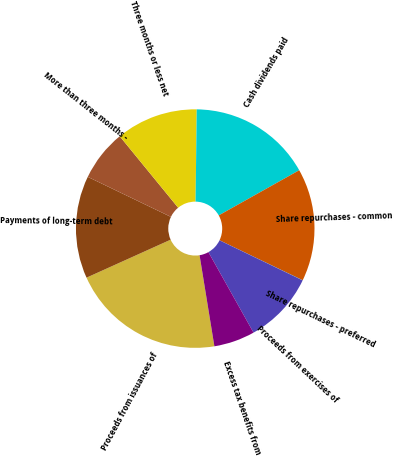<chart> <loc_0><loc_0><loc_500><loc_500><pie_chart><fcel>Proceeds from issuances of<fcel>Payments of long-term debt<fcel>More than three months -<fcel>Three months or less net<fcel>Cash dividends paid<fcel>Share repurchases - common<fcel>Share repurchases - preferred<fcel>Proceeds from exercises of<fcel>Excess tax benefits from<nl><fcel>20.82%<fcel>13.89%<fcel>6.95%<fcel>11.11%<fcel>16.66%<fcel>15.27%<fcel>0.02%<fcel>9.72%<fcel>5.56%<nl></chart> 